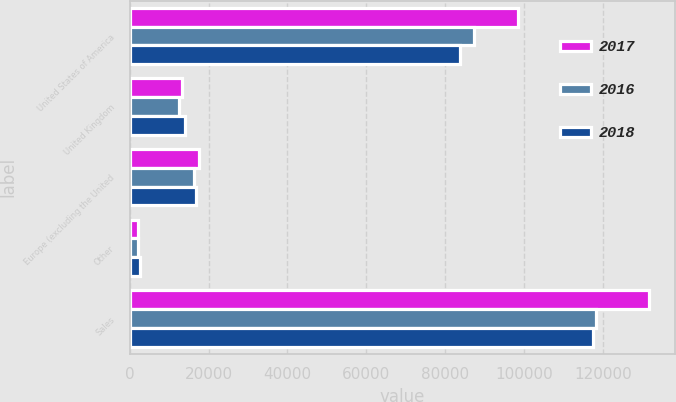Convert chart. <chart><loc_0><loc_0><loc_500><loc_500><stacked_bar_chart><ecel><fcel>United States of America<fcel>United Kingdom<fcel>Europe (excluding the United<fcel>Other<fcel>Sales<nl><fcel>2017<fcel>98392<fcel>13297<fcel>17594<fcel>2254<fcel>131537<nl><fcel>2016<fcel>87302<fcel>12552<fcel>16224<fcel>2136<fcel>118214<nl><fcel>2018<fcel>83802<fcel>14081<fcel>16793<fcel>2675<fcel>117351<nl></chart> 